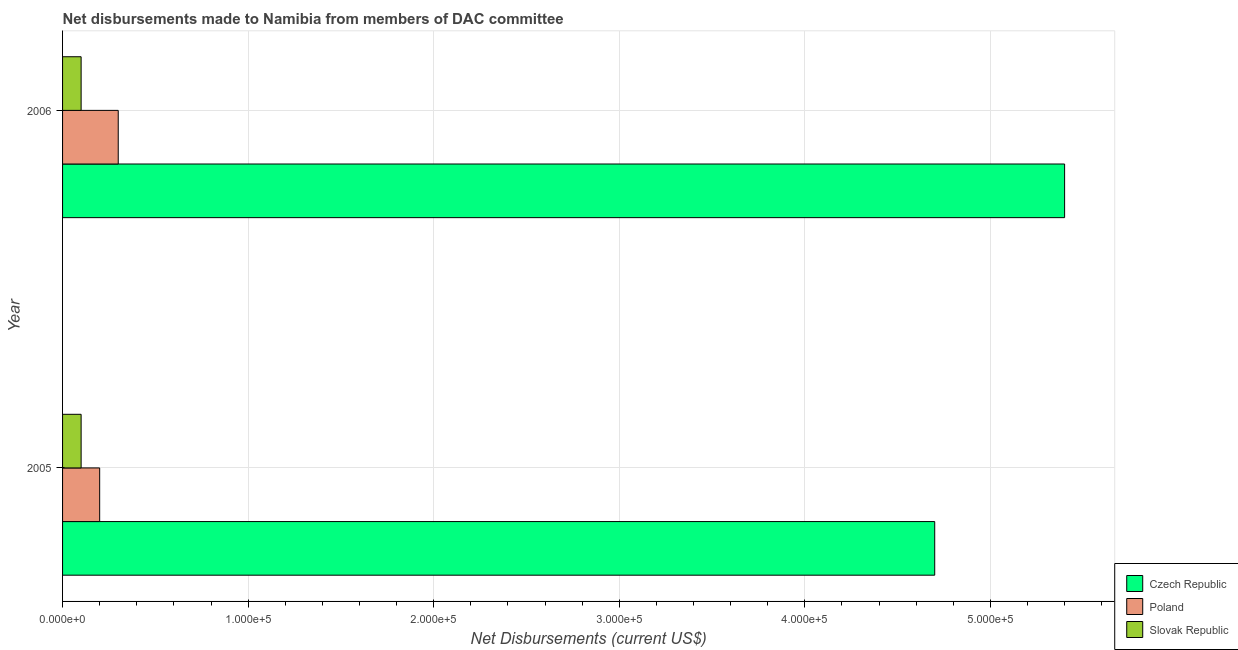How many different coloured bars are there?
Offer a terse response. 3. Are the number of bars on each tick of the Y-axis equal?
Give a very brief answer. Yes. How many bars are there on the 2nd tick from the bottom?
Give a very brief answer. 3. What is the label of the 1st group of bars from the top?
Provide a short and direct response. 2006. In how many cases, is the number of bars for a given year not equal to the number of legend labels?
Make the answer very short. 0. What is the net disbursements made by czech republic in 2005?
Give a very brief answer. 4.70e+05. Across all years, what is the maximum net disbursements made by czech republic?
Make the answer very short. 5.40e+05. Across all years, what is the minimum net disbursements made by slovak republic?
Your answer should be very brief. 10000. In which year was the net disbursements made by slovak republic maximum?
Provide a short and direct response. 2005. What is the total net disbursements made by czech republic in the graph?
Provide a short and direct response. 1.01e+06. What is the difference between the net disbursements made by poland in 2005 and that in 2006?
Provide a short and direct response. -10000. What is the difference between the net disbursements made by poland in 2006 and the net disbursements made by czech republic in 2005?
Offer a very short reply. -4.40e+05. What is the average net disbursements made by poland per year?
Keep it short and to the point. 2.50e+04. In the year 2005, what is the difference between the net disbursements made by czech republic and net disbursements made by poland?
Keep it short and to the point. 4.50e+05. In how many years, is the net disbursements made by poland greater than 140000 US$?
Your answer should be compact. 0. What does the 3rd bar from the top in 2006 represents?
Make the answer very short. Czech Republic. What does the 1st bar from the bottom in 2006 represents?
Provide a succinct answer. Czech Republic. Are all the bars in the graph horizontal?
Make the answer very short. Yes. Does the graph contain grids?
Your answer should be compact. Yes. How are the legend labels stacked?
Make the answer very short. Vertical. What is the title of the graph?
Offer a terse response. Net disbursements made to Namibia from members of DAC committee. Does "Ages 50+" appear as one of the legend labels in the graph?
Your answer should be very brief. No. What is the label or title of the X-axis?
Give a very brief answer. Net Disbursements (current US$). What is the Net Disbursements (current US$) of Poland in 2005?
Your answer should be very brief. 2.00e+04. What is the Net Disbursements (current US$) of Slovak Republic in 2005?
Provide a succinct answer. 10000. What is the Net Disbursements (current US$) in Czech Republic in 2006?
Ensure brevity in your answer.  5.40e+05. Across all years, what is the maximum Net Disbursements (current US$) of Czech Republic?
Your answer should be very brief. 5.40e+05. Across all years, what is the maximum Net Disbursements (current US$) in Slovak Republic?
Your answer should be compact. 10000. Across all years, what is the minimum Net Disbursements (current US$) in Czech Republic?
Offer a very short reply. 4.70e+05. Across all years, what is the minimum Net Disbursements (current US$) in Slovak Republic?
Provide a succinct answer. 10000. What is the total Net Disbursements (current US$) of Czech Republic in the graph?
Your response must be concise. 1.01e+06. What is the total Net Disbursements (current US$) in Poland in the graph?
Offer a very short reply. 5.00e+04. What is the difference between the Net Disbursements (current US$) in Czech Republic in 2005 and that in 2006?
Offer a very short reply. -7.00e+04. What is the difference between the Net Disbursements (current US$) of Poland in 2005 and that in 2006?
Provide a succinct answer. -10000. What is the difference between the Net Disbursements (current US$) in Slovak Republic in 2005 and that in 2006?
Give a very brief answer. 0. What is the difference between the Net Disbursements (current US$) of Poland in 2005 and the Net Disbursements (current US$) of Slovak Republic in 2006?
Provide a short and direct response. 10000. What is the average Net Disbursements (current US$) of Czech Republic per year?
Ensure brevity in your answer.  5.05e+05. What is the average Net Disbursements (current US$) in Poland per year?
Provide a short and direct response. 2.50e+04. What is the average Net Disbursements (current US$) in Slovak Republic per year?
Your response must be concise. 10000. In the year 2005, what is the difference between the Net Disbursements (current US$) in Poland and Net Disbursements (current US$) in Slovak Republic?
Your answer should be compact. 10000. In the year 2006, what is the difference between the Net Disbursements (current US$) in Czech Republic and Net Disbursements (current US$) in Poland?
Give a very brief answer. 5.10e+05. In the year 2006, what is the difference between the Net Disbursements (current US$) in Czech Republic and Net Disbursements (current US$) in Slovak Republic?
Offer a terse response. 5.30e+05. In the year 2006, what is the difference between the Net Disbursements (current US$) in Poland and Net Disbursements (current US$) in Slovak Republic?
Offer a very short reply. 2.00e+04. What is the ratio of the Net Disbursements (current US$) in Czech Republic in 2005 to that in 2006?
Provide a short and direct response. 0.87. What is the ratio of the Net Disbursements (current US$) in Poland in 2005 to that in 2006?
Your answer should be compact. 0.67. What is the difference between the highest and the second highest Net Disbursements (current US$) in Poland?
Your answer should be compact. 10000. 